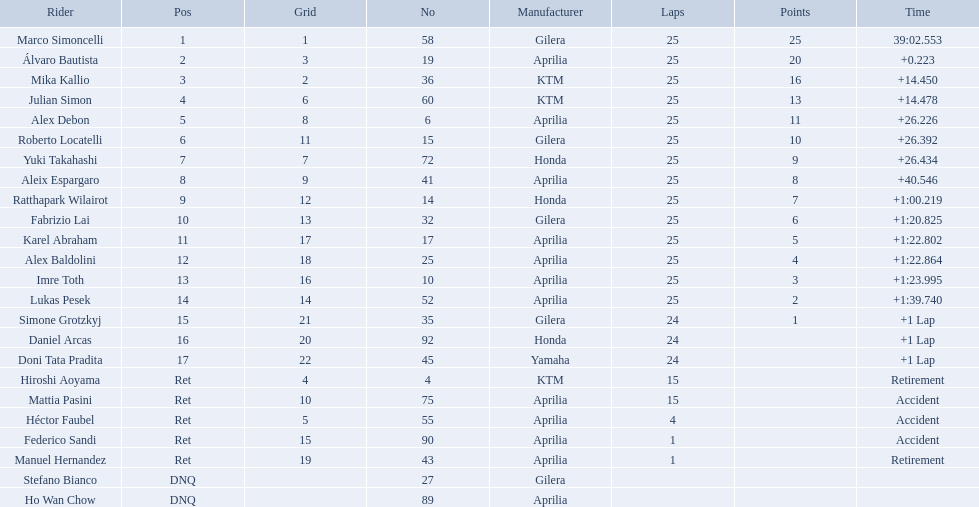What player number is marked #1 for the australian motorcycle grand prix? 58. Who is the rider that represents the #58 in the australian motorcycle grand prix? Marco Simoncelli. Who were all of the riders? Marco Simoncelli, Álvaro Bautista, Mika Kallio, Julian Simon, Alex Debon, Roberto Locatelli, Yuki Takahashi, Aleix Espargaro, Ratthapark Wilairot, Fabrizio Lai, Karel Abraham, Alex Baldolini, Imre Toth, Lukas Pesek, Simone Grotzkyj, Daniel Arcas, Doni Tata Pradita, Hiroshi Aoyama, Mattia Pasini, Héctor Faubel, Federico Sandi, Manuel Hernandez, Stefano Bianco, Ho Wan Chow. How many laps did they complete? 25, 25, 25, 25, 25, 25, 25, 25, 25, 25, 25, 25, 25, 25, 24, 24, 24, 15, 15, 4, 1, 1, , . Between marco simoncelli and hiroshi aoyama, who had more laps? Marco Simoncelli. 